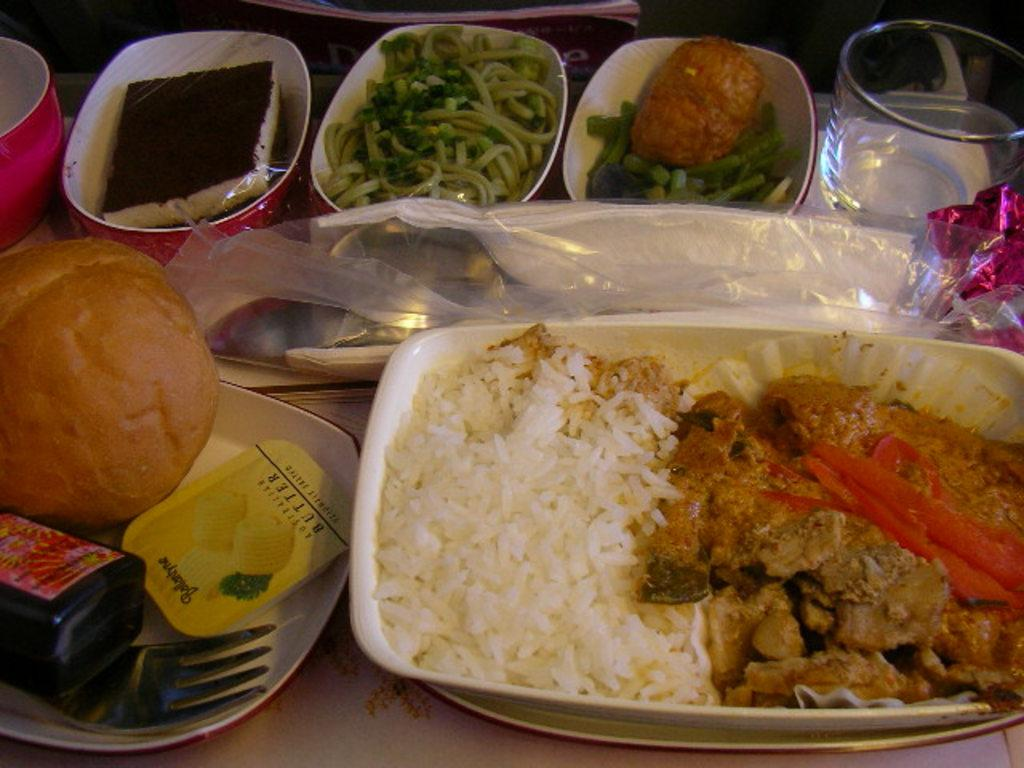What type of utensils can be seen in the image? There are spoons and forks in the image. What else is present on the platform besides utensils? There are bowls, food items, a book, and other objects in the image. What might be used to eat the food items in the image? The spoons and forks in the image can be used to eat the food items. What is the purpose of the book in the image? The purpose of the book in the image is not clear from the facts provided. How many oranges are present on the platform in the image? There is no mention of oranges in the provided facts, so we cannot determine their presence or quantity in the image. What type of pest can be seen crawling on the food items in the image? There is no mention of any pests in the provided facts, so we cannot determine their presence in the image. 